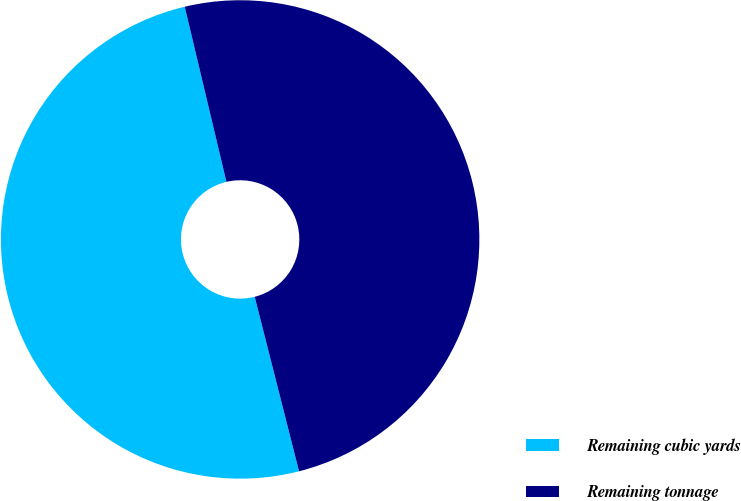Convert chart. <chart><loc_0><loc_0><loc_500><loc_500><pie_chart><fcel>Remaining cubic yards<fcel>Remaining tonnage<nl><fcel>50.24%<fcel>49.76%<nl></chart> 